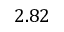<formula> <loc_0><loc_0><loc_500><loc_500>2 . 8 2</formula> 